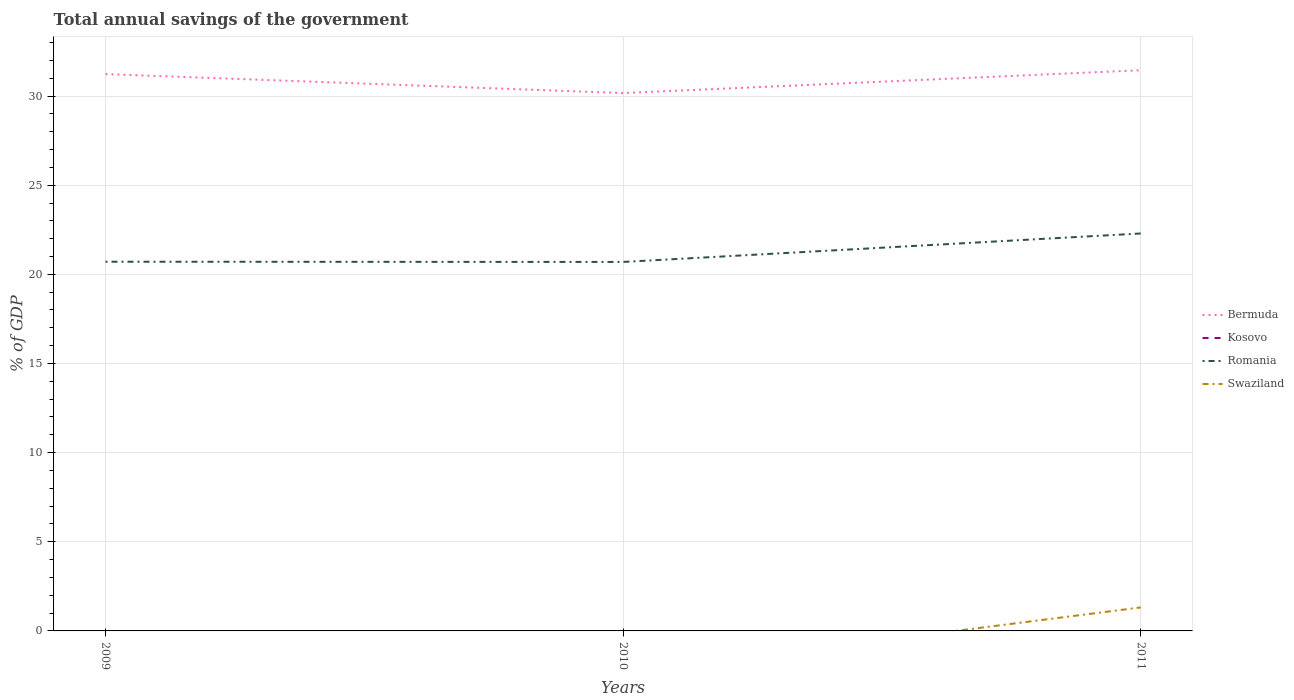How many different coloured lines are there?
Provide a succinct answer. 3. Is the number of lines equal to the number of legend labels?
Provide a succinct answer. No. Across all years, what is the maximum total annual savings of the government in Bermuda?
Keep it short and to the point. 30.17. What is the total total annual savings of the government in Bermuda in the graph?
Give a very brief answer. -0.22. What is the difference between the highest and the second highest total annual savings of the government in Bermuda?
Offer a terse response. 1.28. What is the difference between the highest and the lowest total annual savings of the government in Bermuda?
Make the answer very short. 2. Is the total annual savings of the government in Romania strictly greater than the total annual savings of the government in Bermuda over the years?
Offer a terse response. Yes. How many lines are there?
Provide a short and direct response. 3. How many years are there in the graph?
Your answer should be very brief. 3. Are the values on the major ticks of Y-axis written in scientific E-notation?
Your answer should be very brief. No. Does the graph contain grids?
Your answer should be very brief. Yes. How many legend labels are there?
Make the answer very short. 4. What is the title of the graph?
Keep it short and to the point. Total annual savings of the government. Does "American Samoa" appear as one of the legend labels in the graph?
Offer a terse response. No. What is the label or title of the X-axis?
Keep it short and to the point. Years. What is the label or title of the Y-axis?
Your answer should be very brief. % of GDP. What is the % of GDP in Bermuda in 2009?
Offer a terse response. 31.23. What is the % of GDP of Kosovo in 2009?
Keep it short and to the point. 0. What is the % of GDP in Romania in 2009?
Offer a very short reply. 20.71. What is the % of GDP of Bermuda in 2010?
Your response must be concise. 30.17. What is the % of GDP of Kosovo in 2010?
Provide a succinct answer. 0. What is the % of GDP of Romania in 2010?
Provide a short and direct response. 20.7. What is the % of GDP of Bermuda in 2011?
Your response must be concise. 31.45. What is the % of GDP of Kosovo in 2011?
Offer a terse response. 0. What is the % of GDP in Romania in 2011?
Your response must be concise. 22.29. What is the % of GDP of Swaziland in 2011?
Give a very brief answer. 1.32. Across all years, what is the maximum % of GDP in Bermuda?
Provide a short and direct response. 31.45. Across all years, what is the maximum % of GDP of Romania?
Your answer should be compact. 22.29. Across all years, what is the maximum % of GDP of Swaziland?
Offer a very short reply. 1.32. Across all years, what is the minimum % of GDP of Bermuda?
Give a very brief answer. 30.17. Across all years, what is the minimum % of GDP of Romania?
Your response must be concise. 20.7. Across all years, what is the minimum % of GDP of Swaziland?
Keep it short and to the point. 0. What is the total % of GDP of Bermuda in the graph?
Provide a succinct answer. 92.85. What is the total % of GDP in Romania in the graph?
Ensure brevity in your answer.  63.69. What is the total % of GDP in Swaziland in the graph?
Give a very brief answer. 1.32. What is the difference between the % of GDP in Bermuda in 2009 and that in 2010?
Offer a terse response. 1.06. What is the difference between the % of GDP of Romania in 2009 and that in 2010?
Ensure brevity in your answer.  0.01. What is the difference between the % of GDP of Bermuda in 2009 and that in 2011?
Your answer should be compact. -0.22. What is the difference between the % of GDP in Romania in 2009 and that in 2011?
Keep it short and to the point. -1.58. What is the difference between the % of GDP of Bermuda in 2010 and that in 2011?
Your answer should be very brief. -1.28. What is the difference between the % of GDP of Romania in 2010 and that in 2011?
Give a very brief answer. -1.6. What is the difference between the % of GDP of Bermuda in 2009 and the % of GDP of Romania in 2010?
Provide a succinct answer. 10.54. What is the difference between the % of GDP in Bermuda in 2009 and the % of GDP in Romania in 2011?
Keep it short and to the point. 8.94. What is the difference between the % of GDP of Bermuda in 2009 and the % of GDP of Swaziland in 2011?
Your response must be concise. 29.91. What is the difference between the % of GDP in Romania in 2009 and the % of GDP in Swaziland in 2011?
Offer a terse response. 19.39. What is the difference between the % of GDP of Bermuda in 2010 and the % of GDP of Romania in 2011?
Provide a succinct answer. 7.88. What is the difference between the % of GDP of Bermuda in 2010 and the % of GDP of Swaziland in 2011?
Your answer should be compact. 28.85. What is the difference between the % of GDP of Romania in 2010 and the % of GDP of Swaziland in 2011?
Ensure brevity in your answer.  19.38. What is the average % of GDP in Bermuda per year?
Your answer should be very brief. 30.95. What is the average % of GDP in Romania per year?
Offer a terse response. 21.23. What is the average % of GDP in Swaziland per year?
Your response must be concise. 0.44. In the year 2009, what is the difference between the % of GDP of Bermuda and % of GDP of Romania?
Your answer should be very brief. 10.52. In the year 2010, what is the difference between the % of GDP of Bermuda and % of GDP of Romania?
Provide a short and direct response. 9.47. In the year 2011, what is the difference between the % of GDP in Bermuda and % of GDP in Romania?
Offer a very short reply. 9.16. In the year 2011, what is the difference between the % of GDP of Bermuda and % of GDP of Swaziland?
Keep it short and to the point. 30.13. In the year 2011, what is the difference between the % of GDP of Romania and % of GDP of Swaziland?
Offer a terse response. 20.97. What is the ratio of the % of GDP of Bermuda in 2009 to that in 2010?
Your answer should be compact. 1.04. What is the ratio of the % of GDP of Romania in 2009 to that in 2010?
Provide a succinct answer. 1. What is the ratio of the % of GDP of Bermuda in 2009 to that in 2011?
Your response must be concise. 0.99. What is the ratio of the % of GDP of Romania in 2009 to that in 2011?
Your answer should be very brief. 0.93. What is the ratio of the % of GDP in Bermuda in 2010 to that in 2011?
Make the answer very short. 0.96. What is the ratio of the % of GDP in Romania in 2010 to that in 2011?
Your answer should be compact. 0.93. What is the difference between the highest and the second highest % of GDP in Bermuda?
Your answer should be compact. 0.22. What is the difference between the highest and the second highest % of GDP in Romania?
Ensure brevity in your answer.  1.58. What is the difference between the highest and the lowest % of GDP of Bermuda?
Offer a very short reply. 1.28. What is the difference between the highest and the lowest % of GDP in Romania?
Give a very brief answer. 1.6. What is the difference between the highest and the lowest % of GDP of Swaziland?
Keep it short and to the point. 1.32. 